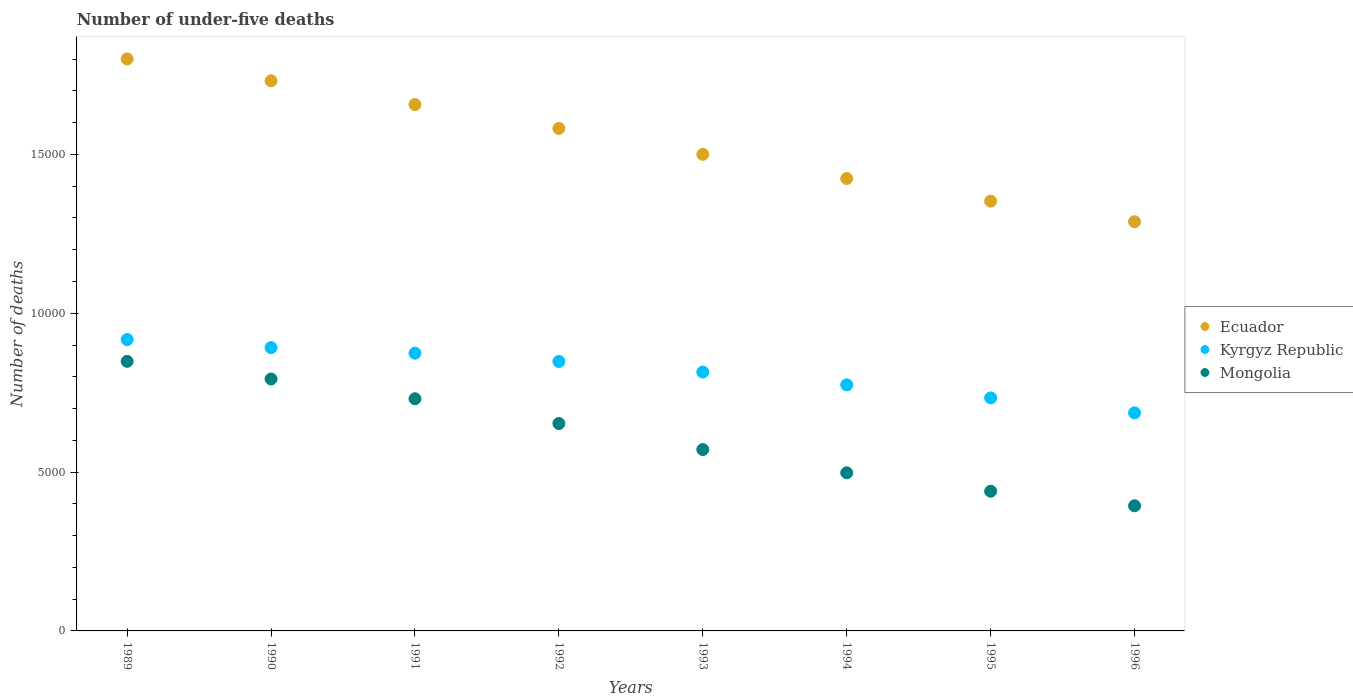How many different coloured dotlines are there?
Provide a short and direct response. 3. What is the number of under-five deaths in Mongolia in 1993?
Your response must be concise. 5709. Across all years, what is the maximum number of under-five deaths in Mongolia?
Offer a terse response. 8486. Across all years, what is the minimum number of under-five deaths in Ecuador?
Ensure brevity in your answer.  1.29e+04. What is the total number of under-five deaths in Mongolia in the graph?
Ensure brevity in your answer.  4.93e+04. What is the difference between the number of under-five deaths in Ecuador in 1993 and that in 1995?
Offer a very short reply. 1473. What is the difference between the number of under-five deaths in Kyrgyz Republic in 1992 and the number of under-five deaths in Ecuador in 1996?
Give a very brief answer. -4400. What is the average number of under-five deaths in Mongolia per year?
Your response must be concise. 6159.5. In the year 1991, what is the difference between the number of under-five deaths in Ecuador and number of under-five deaths in Mongolia?
Offer a terse response. 9261. In how many years, is the number of under-five deaths in Ecuador greater than 13000?
Make the answer very short. 7. What is the ratio of the number of under-five deaths in Ecuador in 1989 to that in 1995?
Keep it short and to the point. 1.33. Is the number of under-five deaths in Ecuador in 1990 less than that in 1995?
Provide a succinct answer. No. What is the difference between the highest and the second highest number of under-five deaths in Kyrgyz Republic?
Keep it short and to the point. 255. What is the difference between the highest and the lowest number of under-five deaths in Mongolia?
Ensure brevity in your answer.  4547. In how many years, is the number of under-five deaths in Ecuador greater than the average number of under-five deaths in Ecuador taken over all years?
Give a very brief answer. 4. Is the sum of the number of under-five deaths in Kyrgyz Republic in 1994 and 1996 greater than the maximum number of under-five deaths in Mongolia across all years?
Make the answer very short. Yes. Does the number of under-five deaths in Ecuador monotonically increase over the years?
Give a very brief answer. No. Is the number of under-five deaths in Mongolia strictly greater than the number of under-five deaths in Ecuador over the years?
Keep it short and to the point. No. Is the number of under-five deaths in Ecuador strictly less than the number of under-five deaths in Kyrgyz Republic over the years?
Your answer should be compact. No. How many dotlines are there?
Offer a very short reply. 3. Are the values on the major ticks of Y-axis written in scientific E-notation?
Offer a very short reply. No. Where does the legend appear in the graph?
Your answer should be very brief. Center right. What is the title of the graph?
Offer a very short reply. Number of under-five deaths. Does "Malta" appear as one of the legend labels in the graph?
Make the answer very short. No. What is the label or title of the X-axis?
Offer a very short reply. Years. What is the label or title of the Y-axis?
Your answer should be very brief. Number of deaths. What is the Number of deaths of Ecuador in 1989?
Make the answer very short. 1.80e+04. What is the Number of deaths in Kyrgyz Republic in 1989?
Your answer should be compact. 9173. What is the Number of deaths of Mongolia in 1989?
Give a very brief answer. 8486. What is the Number of deaths in Ecuador in 1990?
Offer a terse response. 1.73e+04. What is the Number of deaths of Kyrgyz Republic in 1990?
Your response must be concise. 8918. What is the Number of deaths of Mongolia in 1990?
Ensure brevity in your answer.  7930. What is the Number of deaths in Ecuador in 1991?
Keep it short and to the point. 1.66e+04. What is the Number of deaths of Kyrgyz Republic in 1991?
Keep it short and to the point. 8742. What is the Number of deaths of Mongolia in 1991?
Offer a terse response. 7308. What is the Number of deaths in Ecuador in 1992?
Ensure brevity in your answer.  1.58e+04. What is the Number of deaths in Kyrgyz Republic in 1992?
Ensure brevity in your answer.  8482. What is the Number of deaths of Mongolia in 1992?
Offer a very short reply. 6529. What is the Number of deaths in Ecuador in 1993?
Make the answer very short. 1.50e+04. What is the Number of deaths of Kyrgyz Republic in 1993?
Your answer should be very brief. 8149. What is the Number of deaths in Mongolia in 1993?
Give a very brief answer. 5709. What is the Number of deaths in Ecuador in 1994?
Keep it short and to the point. 1.42e+04. What is the Number of deaths of Kyrgyz Republic in 1994?
Your response must be concise. 7745. What is the Number of deaths of Mongolia in 1994?
Give a very brief answer. 4977. What is the Number of deaths in Ecuador in 1995?
Your response must be concise. 1.35e+04. What is the Number of deaths of Kyrgyz Republic in 1995?
Offer a terse response. 7336. What is the Number of deaths in Mongolia in 1995?
Offer a very short reply. 4398. What is the Number of deaths of Ecuador in 1996?
Your answer should be compact. 1.29e+04. What is the Number of deaths of Kyrgyz Republic in 1996?
Provide a succinct answer. 6864. What is the Number of deaths of Mongolia in 1996?
Keep it short and to the point. 3939. Across all years, what is the maximum Number of deaths in Ecuador?
Make the answer very short. 1.80e+04. Across all years, what is the maximum Number of deaths of Kyrgyz Republic?
Provide a succinct answer. 9173. Across all years, what is the maximum Number of deaths of Mongolia?
Ensure brevity in your answer.  8486. Across all years, what is the minimum Number of deaths of Ecuador?
Provide a short and direct response. 1.29e+04. Across all years, what is the minimum Number of deaths of Kyrgyz Republic?
Offer a terse response. 6864. Across all years, what is the minimum Number of deaths of Mongolia?
Offer a very short reply. 3939. What is the total Number of deaths in Ecuador in the graph?
Give a very brief answer. 1.23e+05. What is the total Number of deaths of Kyrgyz Republic in the graph?
Make the answer very short. 6.54e+04. What is the total Number of deaths in Mongolia in the graph?
Provide a succinct answer. 4.93e+04. What is the difference between the Number of deaths of Ecuador in 1989 and that in 1990?
Ensure brevity in your answer.  689. What is the difference between the Number of deaths in Kyrgyz Republic in 1989 and that in 1990?
Make the answer very short. 255. What is the difference between the Number of deaths in Mongolia in 1989 and that in 1990?
Offer a terse response. 556. What is the difference between the Number of deaths of Ecuador in 1989 and that in 1991?
Provide a succinct answer. 1437. What is the difference between the Number of deaths of Kyrgyz Republic in 1989 and that in 1991?
Ensure brevity in your answer.  431. What is the difference between the Number of deaths of Mongolia in 1989 and that in 1991?
Keep it short and to the point. 1178. What is the difference between the Number of deaths of Ecuador in 1989 and that in 1992?
Make the answer very short. 2187. What is the difference between the Number of deaths of Kyrgyz Republic in 1989 and that in 1992?
Offer a very short reply. 691. What is the difference between the Number of deaths in Mongolia in 1989 and that in 1992?
Offer a very short reply. 1957. What is the difference between the Number of deaths of Ecuador in 1989 and that in 1993?
Your response must be concise. 3004. What is the difference between the Number of deaths of Kyrgyz Republic in 1989 and that in 1993?
Your response must be concise. 1024. What is the difference between the Number of deaths in Mongolia in 1989 and that in 1993?
Your answer should be very brief. 2777. What is the difference between the Number of deaths of Ecuador in 1989 and that in 1994?
Your response must be concise. 3765. What is the difference between the Number of deaths of Kyrgyz Republic in 1989 and that in 1994?
Make the answer very short. 1428. What is the difference between the Number of deaths in Mongolia in 1989 and that in 1994?
Offer a very short reply. 3509. What is the difference between the Number of deaths of Ecuador in 1989 and that in 1995?
Ensure brevity in your answer.  4477. What is the difference between the Number of deaths in Kyrgyz Republic in 1989 and that in 1995?
Ensure brevity in your answer.  1837. What is the difference between the Number of deaths in Mongolia in 1989 and that in 1995?
Make the answer very short. 4088. What is the difference between the Number of deaths of Ecuador in 1989 and that in 1996?
Offer a very short reply. 5124. What is the difference between the Number of deaths of Kyrgyz Republic in 1989 and that in 1996?
Keep it short and to the point. 2309. What is the difference between the Number of deaths of Mongolia in 1989 and that in 1996?
Make the answer very short. 4547. What is the difference between the Number of deaths of Ecuador in 1990 and that in 1991?
Provide a short and direct response. 748. What is the difference between the Number of deaths in Kyrgyz Republic in 1990 and that in 1991?
Offer a terse response. 176. What is the difference between the Number of deaths of Mongolia in 1990 and that in 1991?
Your answer should be compact. 622. What is the difference between the Number of deaths of Ecuador in 1990 and that in 1992?
Keep it short and to the point. 1498. What is the difference between the Number of deaths in Kyrgyz Republic in 1990 and that in 1992?
Give a very brief answer. 436. What is the difference between the Number of deaths in Mongolia in 1990 and that in 1992?
Offer a very short reply. 1401. What is the difference between the Number of deaths of Ecuador in 1990 and that in 1993?
Ensure brevity in your answer.  2315. What is the difference between the Number of deaths of Kyrgyz Republic in 1990 and that in 1993?
Your response must be concise. 769. What is the difference between the Number of deaths in Mongolia in 1990 and that in 1993?
Your answer should be compact. 2221. What is the difference between the Number of deaths in Ecuador in 1990 and that in 1994?
Ensure brevity in your answer.  3076. What is the difference between the Number of deaths in Kyrgyz Republic in 1990 and that in 1994?
Ensure brevity in your answer.  1173. What is the difference between the Number of deaths in Mongolia in 1990 and that in 1994?
Your answer should be very brief. 2953. What is the difference between the Number of deaths in Ecuador in 1990 and that in 1995?
Offer a very short reply. 3788. What is the difference between the Number of deaths in Kyrgyz Republic in 1990 and that in 1995?
Make the answer very short. 1582. What is the difference between the Number of deaths of Mongolia in 1990 and that in 1995?
Provide a succinct answer. 3532. What is the difference between the Number of deaths in Ecuador in 1990 and that in 1996?
Provide a short and direct response. 4435. What is the difference between the Number of deaths of Kyrgyz Republic in 1990 and that in 1996?
Give a very brief answer. 2054. What is the difference between the Number of deaths in Mongolia in 1990 and that in 1996?
Your answer should be very brief. 3991. What is the difference between the Number of deaths in Ecuador in 1991 and that in 1992?
Keep it short and to the point. 750. What is the difference between the Number of deaths of Kyrgyz Republic in 1991 and that in 1992?
Your response must be concise. 260. What is the difference between the Number of deaths of Mongolia in 1991 and that in 1992?
Offer a very short reply. 779. What is the difference between the Number of deaths of Ecuador in 1991 and that in 1993?
Offer a very short reply. 1567. What is the difference between the Number of deaths in Kyrgyz Republic in 1991 and that in 1993?
Ensure brevity in your answer.  593. What is the difference between the Number of deaths of Mongolia in 1991 and that in 1993?
Provide a succinct answer. 1599. What is the difference between the Number of deaths of Ecuador in 1991 and that in 1994?
Offer a very short reply. 2328. What is the difference between the Number of deaths in Kyrgyz Republic in 1991 and that in 1994?
Keep it short and to the point. 997. What is the difference between the Number of deaths in Mongolia in 1991 and that in 1994?
Make the answer very short. 2331. What is the difference between the Number of deaths in Ecuador in 1991 and that in 1995?
Offer a terse response. 3040. What is the difference between the Number of deaths in Kyrgyz Republic in 1991 and that in 1995?
Offer a very short reply. 1406. What is the difference between the Number of deaths in Mongolia in 1991 and that in 1995?
Keep it short and to the point. 2910. What is the difference between the Number of deaths in Ecuador in 1991 and that in 1996?
Your answer should be compact. 3687. What is the difference between the Number of deaths of Kyrgyz Republic in 1991 and that in 1996?
Your response must be concise. 1878. What is the difference between the Number of deaths of Mongolia in 1991 and that in 1996?
Provide a short and direct response. 3369. What is the difference between the Number of deaths in Ecuador in 1992 and that in 1993?
Your response must be concise. 817. What is the difference between the Number of deaths of Kyrgyz Republic in 1992 and that in 1993?
Your answer should be compact. 333. What is the difference between the Number of deaths of Mongolia in 1992 and that in 1993?
Keep it short and to the point. 820. What is the difference between the Number of deaths in Ecuador in 1992 and that in 1994?
Provide a short and direct response. 1578. What is the difference between the Number of deaths in Kyrgyz Republic in 1992 and that in 1994?
Offer a very short reply. 737. What is the difference between the Number of deaths in Mongolia in 1992 and that in 1994?
Your answer should be very brief. 1552. What is the difference between the Number of deaths of Ecuador in 1992 and that in 1995?
Provide a succinct answer. 2290. What is the difference between the Number of deaths in Kyrgyz Republic in 1992 and that in 1995?
Your response must be concise. 1146. What is the difference between the Number of deaths of Mongolia in 1992 and that in 1995?
Make the answer very short. 2131. What is the difference between the Number of deaths of Ecuador in 1992 and that in 1996?
Ensure brevity in your answer.  2937. What is the difference between the Number of deaths in Kyrgyz Republic in 1992 and that in 1996?
Your response must be concise. 1618. What is the difference between the Number of deaths of Mongolia in 1992 and that in 1996?
Make the answer very short. 2590. What is the difference between the Number of deaths in Ecuador in 1993 and that in 1994?
Your response must be concise. 761. What is the difference between the Number of deaths in Kyrgyz Republic in 1993 and that in 1994?
Offer a terse response. 404. What is the difference between the Number of deaths in Mongolia in 1993 and that in 1994?
Provide a succinct answer. 732. What is the difference between the Number of deaths of Ecuador in 1993 and that in 1995?
Provide a short and direct response. 1473. What is the difference between the Number of deaths in Kyrgyz Republic in 1993 and that in 1995?
Ensure brevity in your answer.  813. What is the difference between the Number of deaths of Mongolia in 1993 and that in 1995?
Give a very brief answer. 1311. What is the difference between the Number of deaths of Ecuador in 1993 and that in 1996?
Give a very brief answer. 2120. What is the difference between the Number of deaths of Kyrgyz Republic in 1993 and that in 1996?
Offer a terse response. 1285. What is the difference between the Number of deaths of Mongolia in 1993 and that in 1996?
Provide a succinct answer. 1770. What is the difference between the Number of deaths in Ecuador in 1994 and that in 1995?
Ensure brevity in your answer.  712. What is the difference between the Number of deaths of Kyrgyz Republic in 1994 and that in 1995?
Your response must be concise. 409. What is the difference between the Number of deaths in Mongolia in 1994 and that in 1995?
Your answer should be very brief. 579. What is the difference between the Number of deaths of Ecuador in 1994 and that in 1996?
Give a very brief answer. 1359. What is the difference between the Number of deaths of Kyrgyz Republic in 1994 and that in 1996?
Provide a short and direct response. 881. What is the difference between the Number of deaths of Mongolia in 1994 and that in 1996?
Your response must be concise. 1038. What is the difference between the Number of deaths in Ecuador in 1995 and that in 1996?
Offer a terse response. 647. What is the difference between the Number of deaths of Kyrgyz Republic in 1995 and that in 1996?
Your response must be concise. 472. What is the difference between the Number of deaths of Mongolia in 1995 and that in 1996?
Offer a terse response. 459. What is the difference between the Number of deaths in Ecuador in 1989 and the Number of deaths in Kyrgyz Republic in 1990?
Offer a terse response. 9088. What is the difference between the Number of deaths in Ecuador in 1989 and the Number of deaths in Mongolia in 1990?
Ensure brevity in your answer.  1.01e+04. What is the difference between the Number of deaths in Kyrgyz Republic in 1989 and the Number of deaths in Mongolia in 1990?
Your response must be concise. 1243. What is the difference between the Number of deaths of Ecuador in 1989 and the Number of deaths of Kyrgyz Republic in 1991?
Provide a succinct answer. 9264. What is the difference between the Number of deaths of Ecuador in 1989 and the Number of deaths of Mongolia in 1991?
Ensure brevity in your answer.  1.07e+04. What is the difference between the Number of deaths of Kyrgyz Republic in 1989 and the Number of deaths of Mongolia in 1991?
Give a very brief answer. 1865. What is the difference between the Number of deaths in Ecuador in 1989 and the Number of deaths in Kyrgyz Republic in 1992?
Keep it short and to the point. 9524. What is the difference between the Number of deaths of Ecuador in 1989 and the Number of deaths of Mongolia in 1992?
Your answer should be compact. 1.15e+04. What is the difference between the Number of deaths in Kyrgyz Republic in 1989 and the Number of deaths in Mongolia in 1992?
Offer a terse response. 2644. What is the difference between the Number of deaths in Ecuador in 1989 and the Number of deaths in Kyrgyz Republic in 1993?
Provide a succinct answer. 9857. What is the difference between the Number of deaths in Ecuador in 1989 and the Number of deaths in Mongolia in 1993?
Keep it short and to the point. 1.23e+04. What is the difference between the Number of deaths of Kyrgyz Republic in 1989 and the Number of deaths of Mongolia in 1993?
Your answer should be compact. 3464. What is the difference between the Number of deaths in Ecuador in 1989 and the Number of deaths in Kyrgyz Republic in 1994?
Your answer should be very brief. 1.03e+04. What is the difference between the Number of deaths of Ecuador in 1989 and the Number of deaths of Mongolia in 1994?
Offer a very short reply. 1.30e+04. What is the difference between the Number of deaths in Kyrgyz Republic in 1989 and the Number of deaths in Mongolia in 1994?
Your answer should be very brief. 4196. What is the difference between the Number of deaths in Ecuador in 1989 and the Number of deaths in Kyrgyz Republic in 1995?
Make the answer very short. 1.07e+04. What is the difference between the Number of deaths of Ecuador in 1989 and the Number of deaths of Mongolia in 1995?
Provide a succinct answer. 1.36e+04. What is the difference between the Number of deaths of Kyrgyz Republic in 1989 and the Number of deaths of Mongolia in 1995?
Make the answer very short. 4775. What is the difference between the Number of deaths in Ecuador in 1989 and the Number of deaths in Kyrgyz Republic in 1996?
Offer a very short reply. 1.11e+04. What is the difference between the Number of deaths in Ecuador in 1989 and the Number of deaths in Mongolia in 1996?
Give a very brief answer. 1.41e+04. What is the difference between the Number of deaths in Kyrgyz Republic in 1989 and the Number of deaths in Mongolia in 1996?
Your answer should be compact. 5234. What is the difference between the Number of deaths in Ecuador in 1990 and the Number of deaths in Kyrgyz Republic in 1991?
Provide a succinct answer. 8575. What is the difference between the Number of deaths in Ecuador in 1990 and the Number of deaths in Mongolia in 1991?
Provide a succinct answer. 1.00e+04. What is the difference between the Number of deaths of Kyrgyz Republic in 1990 and the Number of deaths of Mongolia in 1991?
Keep it short and to the point. 1610. What is the difference between the Number of deaths of Ecuador in 1990 and the Number of deaths of Kyrgyz Republic in 1992?
Your answer should be very brief. 8835. What is the difference between the Number of deaths in Ecuador in 1990 and the Number of deaths in Mongolia in 1992?
Provide a succinct answer. 1.08e+04. What is the difference between the Number of deaths in Kyrgyz Republic in 1990 and the Number of deaths in Mongolia in 1992?
Your answer should be very brief. 2389. What is the difference between the Number of deaths of Ecuador in 1990 and the Number of deaths of Kyrgyz Republic in 1993?
Provide a succinct answer. 9168. What is the difference between the Number of deaths in Ecuador in 1990 and the Number of deaths in Mongolia in 1993?
Your answer should be compact. 1.16e+04. What is the difference between the Number of deaths in Kyrgyz Republic in 1990 and the Number of deaths in Mongolia in 1993?
Provide a short and direct response. 3209. What is the difference between the Number of deaths in Ecuador in 1990 and the Number of deaths in Kyrgyz Republic in 1994?
Your response must be concise. 9572. What is the difference between the Number of deaths of Ecuador in 1990 and the Number of deaths of Mongolia in 1994?
Provide a short and direct response. 1.23e+04. What is the difference between the Number of deaths in Kyrgyz Republic in 1990 and the Number of deaths in Mongolia in 1994?
Offer a very short reply. 3941. What is the difference between the Number of deaths of Ecuador in 1990 and the Number of deaths of Kyrgyz Republic in 1995?
Make the answer very short. 9981. What is the difference between the Number of deaths of Ecuador in 1990 and the Number of deaths of Mongolia in 1995?
Give a very brief answer. 1.29e+04. What is the difference between the Number of deaths of Kyrgyz Republic in 1990 and the Number of deaths of Mongolia in 1995?
Offer a very short reply. 4520. What is the difference between the Number of deaths of Ecuador in 1990 and the Number of deaths of Kyrgyz Republic in 1996?
Your response must be concise. 1.05e+04. What is the difference between the Number of deaths of Ecuador in 1990 and the Number of deaths of Mongolia in 1996?
Offer a very short reply. 1.34e+04. What is the difference between the Number of deaths of Kyrgyz Republic in 1990 and the Number of deaths of Mongolia in 1996?
Your answer should be very brief. 4979. What is the difference between the Number of deaths in Ecuador in 1991 and the Number of deaths in Kyrgyz Republic in 1992?
Offer a very short reply. 8087. What is the difference between the Number of deaths of Ecuador in 1991 and the Number of deaths of Mongolia in 1992?
Offer a very short reply. 1.00e+04. What is the difference between the Number of deaths of Kyrgyz Republic in 1991 and the Number of deaths of Mongolia in 1992?
Keep it short and to the point. 2213. What is the difference between the Number of deaths of Ecuador in 1991 and the Number of deaths of Kyrgyz Republic in 1993?
Your answer should be very brief. 8420. What is the difference between the Number of deaths in Ecuador in 1991 and the Number of deaths in Mongolia in 1993?
Ensure brevity in your answer.  1.09e+04. What is the difference between the Number of deaths in Kyrgyz Republic in 1991 and the Number of deaths in Mongolia in 1993?
Keep it short and to the point. 3033. What is the difference between the Number of deaths of Ecuador in 1991 and the Number of deaths of Kyrgyz Republic in 1994?
Make the answer very short. 8824. What is the difference between the Number of deaths in Ecuador in 1991 and the Number of deaths in Mongolia in 1994?
Your response must be concise. 1.16e+04. What is the difference between the Number of deaths in Kyrgyz Republic in 1991 and the Number of deaths in Mongolia in 1994?
Your answer should be very brief. 3765. What is the difference between the Number of deaths in Ecuador in 1991 and the Number of deaths in Kyrgyz Republic in 1995?
Give a very brief answer. 9233. What is the difference between the Number of deaths in Ecuador in 1991 and the Number of deaths in Mongolia in 1995?
Keep it short and to the point. 1.22e+04. What is the difference between the Number of deaths in Kyrgyz Republic in 1991 and the Number of deaths in Mongolia in 1995?
Your answer should be very brief. 4344. What is the difference between the Number of deaths of Ecuador in 1991 and the Number of deaths of Kyrgyz Republic in 1996?
Provide a short and direct response. 9705. What is the difference between the Number of deaths in Ecuador in 1991 and the Number of deaths in Mongolia in 1996?
Provide a short and direct response. 1.26e+04. What is the difference between the Number of deaths of Kyrgyz Republic in 1991 and the Number of deaths of Mongolia in 1996?
Ensure brevity in your answer.  4803. What is the difference between the Number of deaths in Ecuador in 1992 and the Number of deaths in Kyrgyz Republic in 1993?
Offer a very short reply. 7670. What is the difference between the Number of deaths of Ecuador in 1992 and the Number of deaths of Mongolia in 1993?
Provide a short and direct response. 1.01e+04. What is the difference between the Number of deaths of Kyrgyz Republic in 1992 and the Number of deaths of Mongolia in 1993?
Your answer should be very brief. 2773. What is the difference between the Number of deaths of Ecuador in 1992 and the Number of deaths of Kyrgyz Republic in 1994?
Your answer should be very brief. 8074. What is the difference between the Number of deaths of Ecuador in 1992 and the Number of deaths of Mongolia in 1994?
Keep it short and to the point. 1.08e+04. What is the difference between the Number of deaths in Kyrgyz Republic in 1992 and the Number of deaths in Mongolia in 1994?
Offer a very short reply. 3505. What is the difference between the Number of deaths in Ecuador in 1992 and the Number of deaths in Kyrgyz Republic in 1995?
Provide a short and direct response. 8483. What is the difference between the Number of deaths of Ecuador in 1992 and the Number of deaths of Mongolia in 1995?
Make the answer very short. 1.14e+04. What is the difference between the Number of deaths of Kyrgyz Republic in 1992 and the Number of deaths of Mongolia in 1995?
Offer a terse response. 4084. What is the difference between the Number of deaths in Ecuador in 1992 and the Number of deaths in Kyrgyz Republic in 1996?
Your answer should be very brief. 8955. What is the difference between the Number of deaths in Ecuador in 1992 and the Number of deaths in Mongolia in 1996?
Ensure brevity in your answer.  1.19e+04. What is the difference between the Number of deaths of Kyrgyz Republic in 1992 and the Number of deaths of Mongolia in 1996?
Give a very brief answer. 4543. What is the difference between the Number of deaths of Ecuador in 1993 and the Number of deaths of Kyrgyz Republic in 1994?
Give a very brief answer. 7257. What is the difference between the Number of deaths of Ecuador in 1993 and the Number of deaths of Mongolia in 1994?
Provide a short and direct response. 1.00e+04. What is the difference between the Number of deaths in Kyrgyz Republic in 1993 and the Number of deaths in Mongolia in 1994?
Keep it short and to the point. 3172. What is the difference between the Number of deaths of Ecuador in 1993 and the Number of deaths of Kyrgyz Republic in 1995?
Keep it short and to the point. 7666. What is the difference between the Number of deaths of Ecuador in 1993 and the Number of deaths of Mongolia in 1995?
Keep it short and to the point. 1.06e+04. What is the difference between the Number of deaths of Kyrgyz Republic in 1993 and the Number of deaths of Mongolia in 1995?
Your response must be concise. 3751. What is the difference between the Number of deaths of Ecuador in 1993 and the Number of deaths of Kyrgyz Republic in 1996?
Offer a terse response. 8138. What is the difference between the Number of deaths in Ecuador in 1993 and the Number of deaths in Mongolia in 1996?
Keep it short and to the point. 1.11e+04. What is the difference between the Number of deaths of Kyrgyz Republic in 1993 and the Number of deaths of Mongolia in 1996?
Provide a succinct answer. 4210. What is the difference between the Number of deaths of Ecuador in 1994 and the Number of deaths of Kyrgyz Republic in 1995?
Your answer should be very brief. 6905. What is the difference between the Number of deaths of Ecuador in 1994 and the Number of deaths of Mongolia in 1995?
Ensure brevity in your answer.  9843. What is the difference between the Number of deaths in Kyrgyz Republic in 1994 and the Number of deaths in Mongolia in 1995?
Keep it short and to the point. 3347. What is the difference between the Number of deaths in Ecuador in 1994 and the Number of deaths in Kyrgyz Republic in 1996?
Keep it short and to the point. 7377. What is the difference between the Number of deaths in Ecuador in 1994 and the Number of deaths in Mongolia in 1996?
Provide a short and direct response. 1.03e+04. What is the difference between the Number of deaths in Kyrgyz Republic in 1994 and the Number of deaths in Mongolia in 1996?
Your response must be concise. 3806. What is the difference between the Number of deaths of Ecuador in 1995 and the Number of deaths of Kyrgyz Republic in 1996?
Offer a terse response. 6665. What is the difference between the Number of deaths in Ecuador in 1995 and the Number of deaths in Mongolia in 1996?
Your answer should be very brief. 9590. What is the difference between the Number of deaths of Kyrgyz Republic in 1995 and the Number of deaths of Mongolia in 1996?
Make the answer very short. 3397. What is the average Number of deaths of Ecuador per year?
Provide a succinct answer. 1.54e+04. What is the average Number of deaths in Kyrgyz Republic per year?
Give a very brief answer. 8176.12. What is the average Number of deaths in Mongolia per year?
Offer a very short reply. 6159.5. In the year 1989, what is the difference between the Number of deaths of Ecuador and Number of deaths of Kyrgyz Republic?
Ensure brevity in your answer.  8833. In the year 1989, what is the difference between the Number of deaths in Ecuador and Number of deaths in Mongolia?
Give a very brief answer. 9520. In the year 1989, what is the difference between the Number of deaths of Kyrgyz Republic and Number of deaths of Mongolia?
Keep it short and to the point. 687. In the year 1990, what is the difference between the Number of deaths in Ecuador and Number of deaths in Kyrgyz Republic?
Keep it short and to the point. 8399. In the year 1990, what is the difference between the Number of deaths of Ecuador and Number of deaths of Mongolia?
Make the answer very short. 9387. In the year 1990, what is the difference between the Number of deaths of Kyrgyz Republic and Number of deaths of Mongolia?
Keep it short and to the point. 988. In the year 1991, what is the difference between the Number of deaths in Ecuador and Number of deaths in Kyrgyz Republic?
Offer a very short reply. 7827. In the year 1991, what is the difference between the Number of deaths in Ecuador and Number of deaths in Mongolia?
Provide a short and direct response. 9261. In the year 1991, what is the difference between the Number of deaths in Kyrgyz Republic and Number of deaths in Mongolia?
Your answer should be compact. 1434. In the year 1992, what is the difference between the Number of deaths of Ecuador and Number of deaths of Kyrgyz Republic?
Ensure brevity in your answer.  7337. In the year 1992, what is the difference between the Number of deaths of Ecuador and Number of deaths of Mongolia?
Offer a terse response. 9290. In the year 1992, what is the difference between the Number of deaths in Kyrgyz Republic and Number of deaths in Mongolia?
Keep it short and to the point. 1953. In the year 1993, what is the difference between the Number of deaths of Ecuador and Number of deaths of Kyrgyz Republic?
Offer a terse response. 6853. In the year 1993, what is the difference between the Number of deaths in Ecuador and Number of deaths in Mongolia?
Keep it short and to the point. 9293. In the year 1993, what is the difference between the Number of deaths of Kyrgyz Republic and Number of deaths of Mongolia?
Provide a succinct answer. 2440. In the year 1994, what is the difference between the Number of deaths in Ecuador and Number of deaths in Kyrgyz Republic?
Make the answer very short. 6496. In the year 1994, what is the difference between the Number of deaths in Ecuador and Number of deaths in Mongolia?
Offer a terse response. 9264. In the year 1994, what is the difference between the Number of deaths of Kyrgyz Republic and Number of deaths of Mongolia?
Give a very brief answer. 2768. In the year 1995, what is the difference between the Number of deaths in Ecuador and Number of deaths in Kyrgyz Republic?
Make the answer very short. 6193. In the year 1995, what is the difference between the Number of deaths in Ecuador and Number of deaths in Mongolia?
Your answer should be very brief. 9131. In the year 1995, what is the difference between the Number of deaths in Kyrgyz Republic and Number of deaths in Mongolia?
Provide a short and direct response. 2938. In the year 1996, what is the difference between the Number of deaths in Ecuador and Number of deaths in Kyrgyz Republic?
Give a very brief answer. 6018. In the year 1996, what is the difference between the Number of deaths in Ecuador and Number of deaths in Mongolia?
Your answer should be very brief. 8943. In the year 1996, what is the difference between the Number of deaths of Kyrgyz Republic and Number of deaths of Mongolia?
Offer a terse response. 2925. What is the ratio of the Number of deaths in Ecuador in 1989 to that in 1990?
Make the answer very short. 1.04. What is the ratio of the Number of deaths of Kyrgyz Republic in 1989 to that in 1990?
Make the answer very short. 1.03. What is the ratio of the Number of deaths in Mongolia in 1989 to that in 1990?
Offer a very short reply. 1.07. What is the ratio of the Number of deaths in Ecuador in 1989 to that in 1991?
Offer a terse response. 1.09. What is the ratio of the Number of deaths of Kyrgyz Republic in 1989 to that in 1991?
Offer a very short reply. 1.05. What is the ratio of the Number of deaths in Mongolia in 1989 to that in 1991?
Give a very brief answer. 1.16. What is the ratio of the Number of deaths in Ecuador in 1989 to that in 1992?
Ensure brevity in your answer.  1.14. What is the ratio of the Number of deaths of Kyrgyz Republic in 1989 to that in 1992?
Offer a very short reply. 1.08. What is the ratio of the Number of deaths of Mongolia in 1989 to that in 1992?
Your answer should be compact. 1.3. What is the ratio of the Number of deaths of Ecuador in 1989 to that in 1993?
Provide a succinct answer. 1.2. What is the ratio of the Number of deaths of Kyrgyz Republic in 1989 to that in 1993?
Provide a short and direct response. 1.13. What is the ratio of the Number of deaths in Mongolia in 1989 to that in 1993?
Your answer should be very brief. 1.49. What is the ratio of the Number of deaths in Ecuador in 1989 to that in 1994?
Keep it short and to the point. 1.26. What is the ratio of the Number of deaths in Kyrgyz Republic in 1989 to that in 1994?
Ensure brevity in your answer.  1.18. What is the ratio of the Number of deaths in Mongolia in 1989 to that in 1994?
Give a very brief answer. 1.71. What is the ratio of the Number of deaths in Ecuador in 1989 to that in 1995?
Give a very brief answer. 1.33. What is the ratio of the Number of deaths of Kyrgyz Republic in 1989 to that in 1995?
Provide a short and direct response. 1.25. What is the ratio of the Number of deaths in Mongolia in 1989 to that in 1995?
Ensure brevity in your answer.  1.93. What is the ratio of the Number of deaths in Ecuador in 1989 to that in 1996?
Offer a very short reply. 1.4. What is the ratio of the Number of deaths in Kyrgyz Republic in 1989 to that in 1996?
Provide a succinct answer. 1.34. What is the ratio of the Number of deaths of Mongolia in 1989 to that in 1996?
Give a very brief answer. 2.15. What is the ratio of the Number of deaths of Ecuador in 1990 to that in 1991?
Provide a succinct answer. 1.05. What is the ratio of the Number of deaths of Kyrgyz Republic in 1990 to that in 1991?
Make the answer very short. 1.02. What is the ratio of the Number of deaths in Mongolia in 1990 to that in 1991?
Keep it short and to the point. 1.09. What is the ratio of the Number of deaths of Ecuador in 1990 to that in 1992?
Keep it short and to the point. 1.09. What is the ratio of the Number of deaths in Kyrgyz Republic in 1990 to that in 1992?
Your answer should be very brief. 1.05. What is the ratio of the Number of deaths in Mongolia in 1990 to that in 1992?
Your response must be concise. 1.21. What is the ratio of the Number of deaths of Ecuador in 1990 to that in 1993?
Your answer should be very brief. 1.15. What is the ratio of the Number of deaths in Kyrgyz Republic in 1990 to that in 1993?
Your response must be concise. 1.09. What is the ratio of the Number of deaths in Mongolia in 1990 to that in 1993?
Your answer should be very brief. 1.39. What is the ratio of the Number of deaths of Ecuador in 1990 to that in 1994?
Your answer should be compact. 1.22. What is the ratio of the Number of deaths of Kyrgyz Republic in 1990 to that in 1994?
Ensure brevity in your answer.  1.15. What is the ratio of the Number of deaths in Mongolia in 1990 to that in 1994?
Offer a very short reply. 1.59. What is the ratio of the Number of deaths in Ecuador in 1990 to that in 1995?
Offer a very short reply. 1.28. What is the ratio of the Number of deaths of Kyrgyz Republic in 1990 to that in 1995?
Make the answer very short. 1.22. What is the ratio of the Number of deaths in Mongolia in 1990 to that in 1995?
Offer a terse response. 1.8. What is the ratio of the Number of deaths of Ecuador in 1990 to that in 1996?
Give a very brief answer. 1.34. What is the ratio of the Number of deaths of Kyrgyz Republic in 1990 to that in 1996?
Offer a terse response. 1.3. What is the ratio of the Number of deaths of Mongolia in 1990 to that in 1996?
Your answer should be very brief. 2.01. What is the ratio of the Number of deaths in Ecuador in 1991 to that in 1992?
Your answer should be compact. 1.05. What is the ratio of the Number of deaths of Kyrgyz Republic in 1991 to that in 1992?
Offer a very short reply. 1.03. What is the ratio of the Number of deaths in Mongolia in 1991 to that in 1992?
Your response must be concise. 1.12. What is the ratio of the Number of deaths in Ecuador in 1991 to that in 1993?
Your answer should be very brief. 1.1. What is the ratio of the Number of deaths in Kyrgyz Republic in 1991 to that in 1993?
Provide a succinct answer. 1.07. What is the ratio of the Number of deaths of Mongolia in 1991 to that in 1993?
Your response must be concise. 1.28. What is the ratio of the Number of deaths in Ecuador in 1991 to that in 1994?
Your response must be concise. 1.16. What is the ratio of the Number of deaths of Kyrgyz Republic in 1991 to that in 1994?
Your answer should be compact. 1.13. What is the ratio of the Number of deaths of Mongolia in 1991 to that in 1994?
Your answer should be compact. 1.47. What is the ratio of the Number of deaths of Ecuador in 1991 to that in 1995?
Provide a succinct answer. 1.22. What is the ratio of the Number of deaths of Kyrgyz Republic in 1991 to that in 1995?
Your answer should be compact. 1.19. What is the ratio of the Number of deaths of Mongolia in 1991 to that in 1995?
Offer a terse response. 1.66. What is the ratio of the Number of deaths of Ecuador in 1991 to that in 1996?
Your response must be concise. 1.29. What is the ratio of the Number of deaths in Kyrgyz Republic in 1991 to that in 1996?
Make the answer very short. 1.27. What is the ratio of the Number of deaths of Mongolia in 1991 to that in 1996?
Offer a very short reply. 1.86. What is the ratio of the Number of deaths in Ecuador in 1992 to that in 1993?
Make the answer very short. 1.05. What is the ratio of the Number of deaths in Kyrgyz Republic in 1992 to that in 1993?
Provide a short and direct response. 1.04. What is the ratio of the Number of deaths in Mongolia in 1992 to that in 1993?
Your answer should be very brief. 1.14. What is the ratio of the Number of deaths of Ecuador in 1992 to that in 1994?
Ensure brevity in your answer.  1.11. What is the ratio of the Number of deaths of Kyrgyz Republic in 1992 to that in 1994?
Offer a very short reply. 1.1. What is the ratio of the Number of deaths of Mongolia in 1992 to that in 1994?
Make the answer very short. 1.31. What is the ratio of the Number of deaths in Ecuador in 1992 to that in 1995?
Ensure brevity in your answer.  1.17. What is the ratio of the Number of deaths of Kyrgyz Republic in 1992 to that in 1995?
Give a very brief answer. 1.16. What is the ratio of the Number of deaths of Mongolia in 1992 to that in 1995?
Provide a succinct answer. 1.48. What is the ratio of the Number of deaths in Ecuador in 1992 to that in 1996?
Your answer should be very brief. 1.23. What is the ratio of the Number of deaths in Kyrgyz Republic in 1992 to that in 1996?
Provide a short and direct response. 1.24. What is the ratio of the Number of deaths in Mongolia in 1992 to that in 1996?
Your response must be concise. 1.66. What is the ratio of the Number of deaths of Ecuador in 1993 to that in 1994?
Offer a very short reply. 1.05. What is the ratio of the Number of deaths of Kyrgyz Republic in 1993 to that in 1994?
Give a very brief answer. 1.05. What is the ratio of the Number of deaths of Mongolia in 1993 to that in 1994?
Offer a very short reply. 1.15. What is the ratio of the Number of deaths of Ecuador in 1993 to that in 1995?
Provide a short and direct response. 1.11. What is the ratio of the Number of deaths in Kyrgyz Republic in 1993 to that in 1995?
Your response must be concise. 1.11. What is the ratio of the Number of deaths in Mongolia in 1993 to that in 1995?
Your answer should be very brief. 1.3. What is the ratio of the Number of deaths of Ecuador in 1993 to that in 1996?
Provide a succinct answer. 1.16. What is the ratio of the Number of deaths in Kyrgyz Republic in 1993 to that in 1996?
Offer a terse response. 1.19. What is the ratio of the Number of deaths in Mongolia in 1993 to that in 1996?
Ensure brevity in your answer.  1.45. What is the ratio of the Number of deaths of Ecuador in 1994 to that in 1995?
Your answer should be compact. 1.05. What is the ratio of the Number of deaths in Kyrgyz Republic in 1994 to that in 1995?
Your answer should be compact. 1.06. What is the ratio of the Number of deaths in Mongolia in 1994 to that in 1995?
Your response must be concise. 1.13. What is the ratio of the Number of deaths of Ecuador in 1994 to that in 1996?
Keep it short and to the point. 1.11. What is the ratio of the Number of deaths of Kyrgyz Republic in 1994 to that in 1996?
Your answer should be compact. 1.13. What is the ratio of the Number of deaths in Mongolia in 1994 to that in 1996?
Ensure brevity in your answer.  1.26. What is the ratio of the Number of deaths in Ecuador in 1995 to that in 1996?
Provide a short and direct response. 1.05. What is the ratio of the Number of deaths of Kyrgyz Republic in 1995 to that in 1996?
Provide a succinct answer. 1.07. What is the ratio of the Number of deaths in Mongolia in 1995 to that in 1996?
Provide a succinct answer. 1.12. What is the difference between the highest and the second highest Number of deaths of Ecuador?
Provide a short and direct response. 689. What is the difference between the highest and the second highest Number of deaths in Kyrgyz Republic?
Ensure brevity in your answer.  255. What is the difference between the highest and the second highest Number of deaths in Mongolia?
Give a very brief answer. 556. What is the difference between the highest and the lowest Number of deaths of Ecuador?
Give a very brief answer. 5124. What is the difference between the highest and the lowest Number of deaths of Kyrgyz Republic?
Keep it short and to the point. 2309. What is the difference between the highest and the lowest Number of deaths of Mongolia?
Give a very brief answer. 4547. 